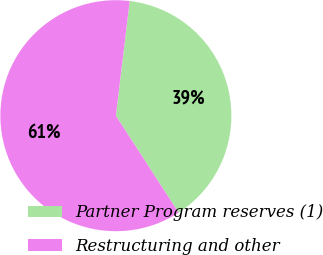Convert chart. <chart><loc_0><loc_0><loc_500><loc_500><pie_chart><fcel>Partner Program reserves (1)<fcel>Restructuring and other<nl><fcel>38.95%<fcel>61.05%<nl></chart> 